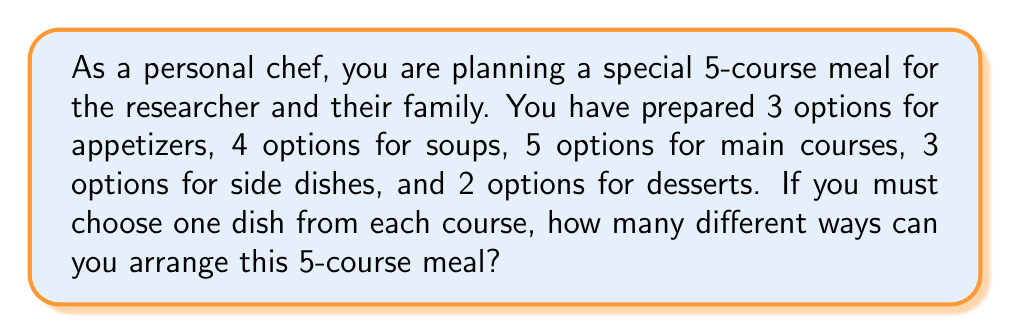Help me with this question. To solve this problem, we'll use the multiplication principle of counting. This principle states that if we have a sequence of independent choices, the total number of ways to make these choices is the product of the number of ways to make each individual choice.

Let's break down the problem:

1. Appetizers: 3 options
2. Soups: 4 options
3. Main courses: 5 options
4. Side dishes: 3 options
5. Desserts: 2 options

For each course, we are selecting one option. The choices for each course are independent of the others. Therefore, we can multiply the number of options for each course to get the total number of possible meal arrangements.

The calculation is as follows:

$$ \text{Total arrangements} = 3 \times 4 \times 5 \times 3 \times 2 $$

Let's compute this:

$$ \begin{align}
\text{Total arrangements} &= 3 \times 4 \times 5 \times 3 \times 2 \\
&= 12 \times 5 \times 3 \times 2 \\
&= 60 \times 3 \times 2 \\
&= 180 \times 2 \\
&= 360
\end{align} $$

Therefore, there are 360 different ways to arrange this 5-course meal.
Answer: 360 ways 